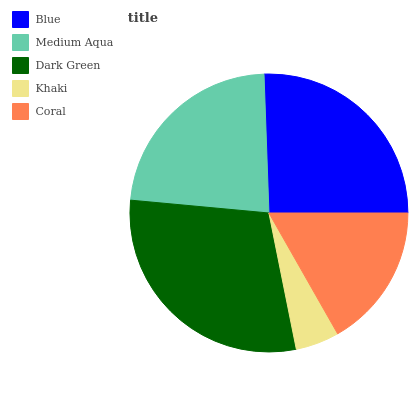Is Khaki the minimum?
Answer yes or no. Yes. Is Dark Green the maximum?
Answer yes or no. Yes. Is Medium Aqua the minimum?
Answer yes or no. No. Is Medium Aqua the maximum?
Answer yes or no. No. Is Blue greater than Medium Aqua?
Answer yes or no. Yes. Is Medium Aqua less than Blue?
Answer yes or no. Yes. Is Medium Aqua greater than Blue?
Answer yes or no. No. Is Blue less than Medium Aqua?
Answer yes or no. No. Is Medium Aqua the high median?
Answer yes or no. Yes. Is Medium Aqua the low median?
Answer yes or no. Yes. Is Dark Green the high median?
Answer yes or no. No. Is Coral the low median?
Answer yes or no. No. 